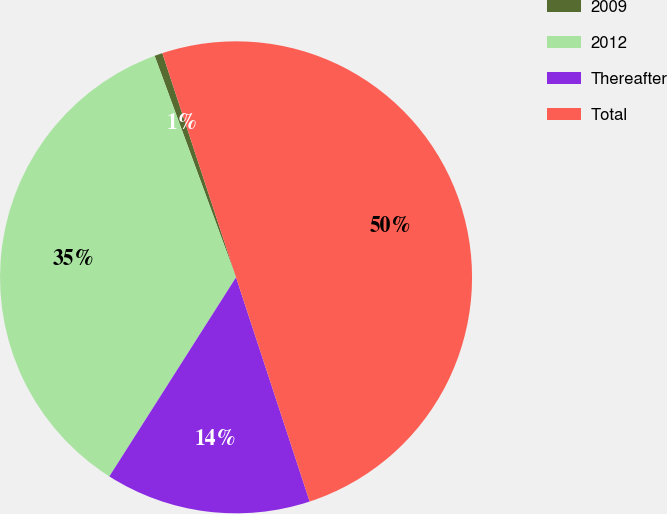<chart> <loc_0><loc_0><loc_500><loc_500><pie_chart><fcel>2009<fcel>2012<fcel>Thereafter<fcel>Total<nl><fcel>0.55%<fcel>35.37%<fcel>14.07%<fcel>50.0%<nl></chart> 